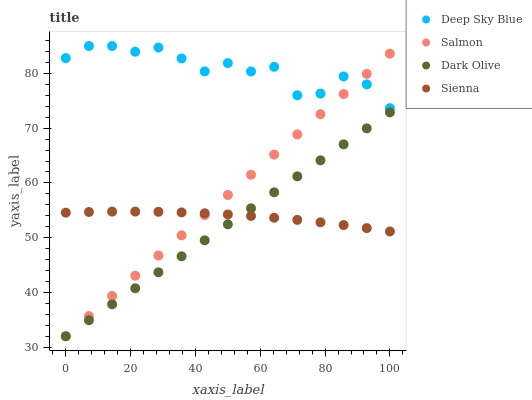Does Dark Olive have the minimum area under the curve?
Answer yes or no. Yes. Does Deep Sky Blue have the maximum area under the curve?
Answer yes or no. Yes. Does Salmon have the minimum area under the curve?
Answer yes or no. No. Does Salmon have the maximum area under the curve?
Answer yes or no. No. Is Dark Olive the smoothest?
Answer yes or no. Yes. Is Deep Sky Blue the roughest?
Answer yes or no. Yes. Is Salmon the smoothest?
Answer yes or no. No. Is Salmon the roughest?
Answer yes or no. No. Does Dark Olive have the lowest value?
Answer yes or no. Yes. Does Deep Sky Blue have the lowest value?
Answer yes or no. No. Does Deep Sky Blue have the highest value?
Answer yes or no. Yes. Does Dark Olive have the highest value?
Answer yes or no. No. Is Dark Olive less than Deep Sky Blue?
Answer yes or no. Yes. Is Deep Sky Blue greater than Sienna?
Answer yes or no. Yes. Does Dark Olive intersect Sienna?
Answer yes or no. Yes. Is Dark Olive less than Sienna?
Answer yes or no. No. Is Dark Olive greater than Sienna?
Answer yes or no. No. Does Dark Olive intersect Deep Sky Blue?
Answer yes or no. No. 